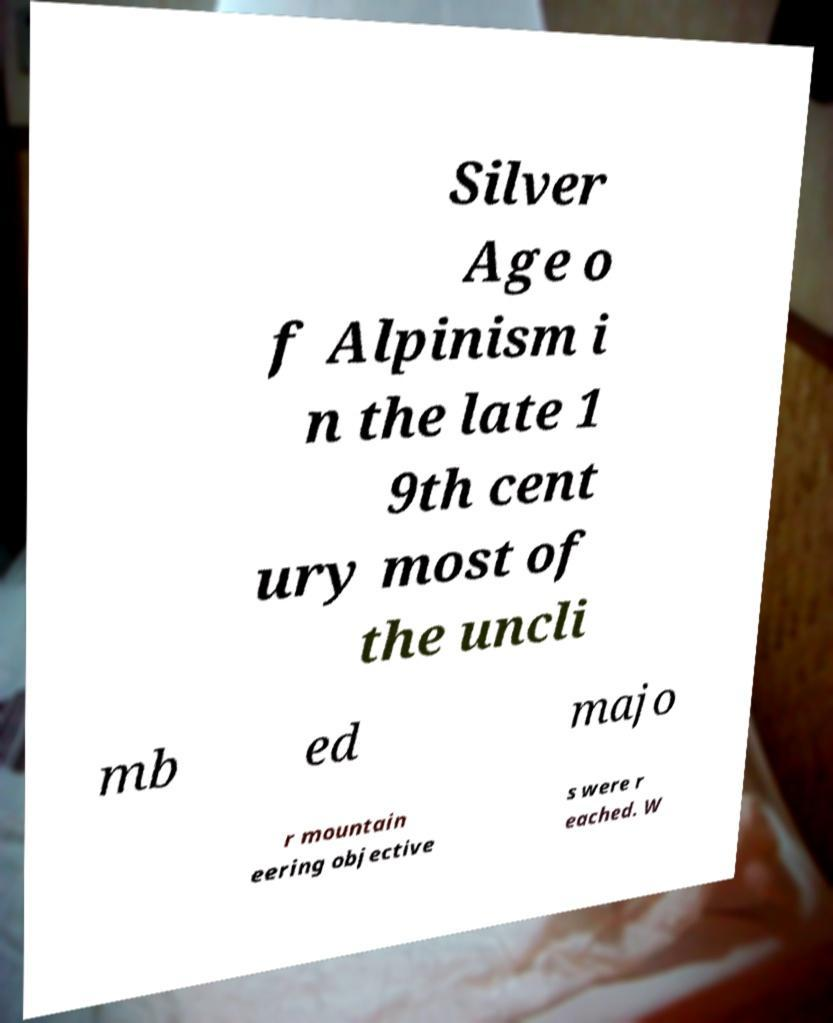Could you extract and type out the text from this image? Silver Age o f Alpinism i n the late 1 9th cent ury most of the uncli mb ed majo r mountain eering objective s were r eached. W 